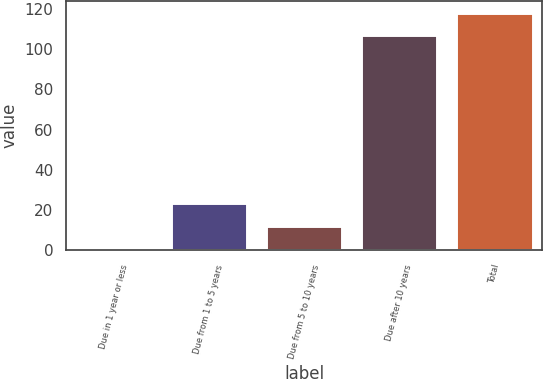<chart> <loc_0><loc_0><loc_500><loc_500><bar_chart><fcel>Due in 1 year or less<fcel>Due from 1 to 5 years<fcel>Due from 5 to 10 years<fcel>Due after 10 years<fcel>Total<nl><fcel>1<fcel>23.4<fcel>12.2<fcel>107<fcel>118.2<nl></chart> 